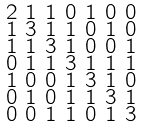Convert formula to latex. <formula><loc_0><loc_0><loc_500><loc_500>\begin{smallmatrix} 2 & 1 & 1 & 0 & 1 & 0 & 0 \\ 1 & 3 & 1 & 1 & 0 & 1 & 0 \\ 1 & 1 & 3 & 1 & 0 & 0 & 1 \\ 0 & 1 & 1 & 3 & 1 & 1 & 1 \\ 1 & 0 & 0 & 1 & 3 & 1 & 0 \\ 0 & 1 & 0 & 1 & 1 & 3 & 1 \\ 0 & 0 & 1 & 1 & 0 & 1 & 3 \end{smallmatrix}</formula> 